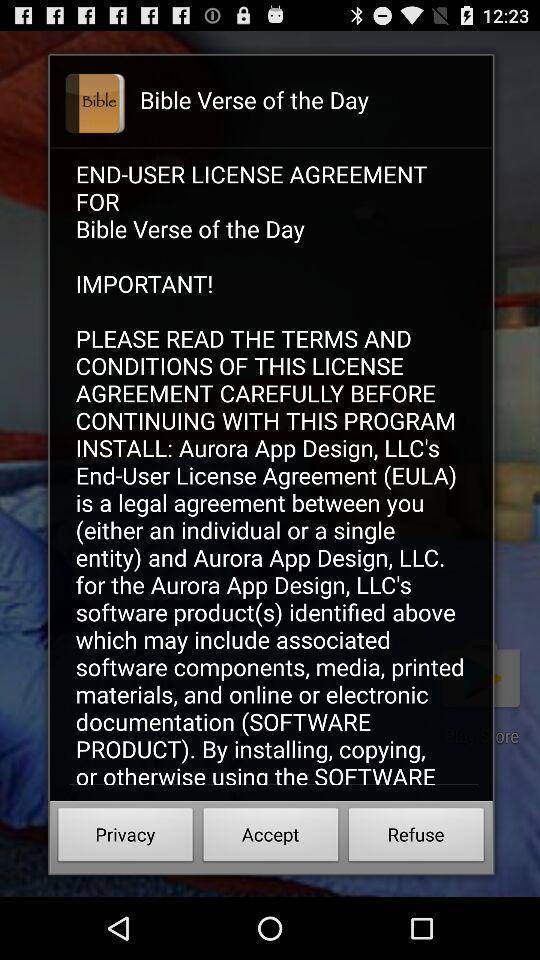What details can you identify in this image? Pop-up showing a reminder to read terms and conditions. 